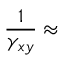Convert formula to latex. <formula><loc_0><loc_0><loc_500><loc_500>\frac { 1 } { \gamma _ { x y } } \approx</formula> 